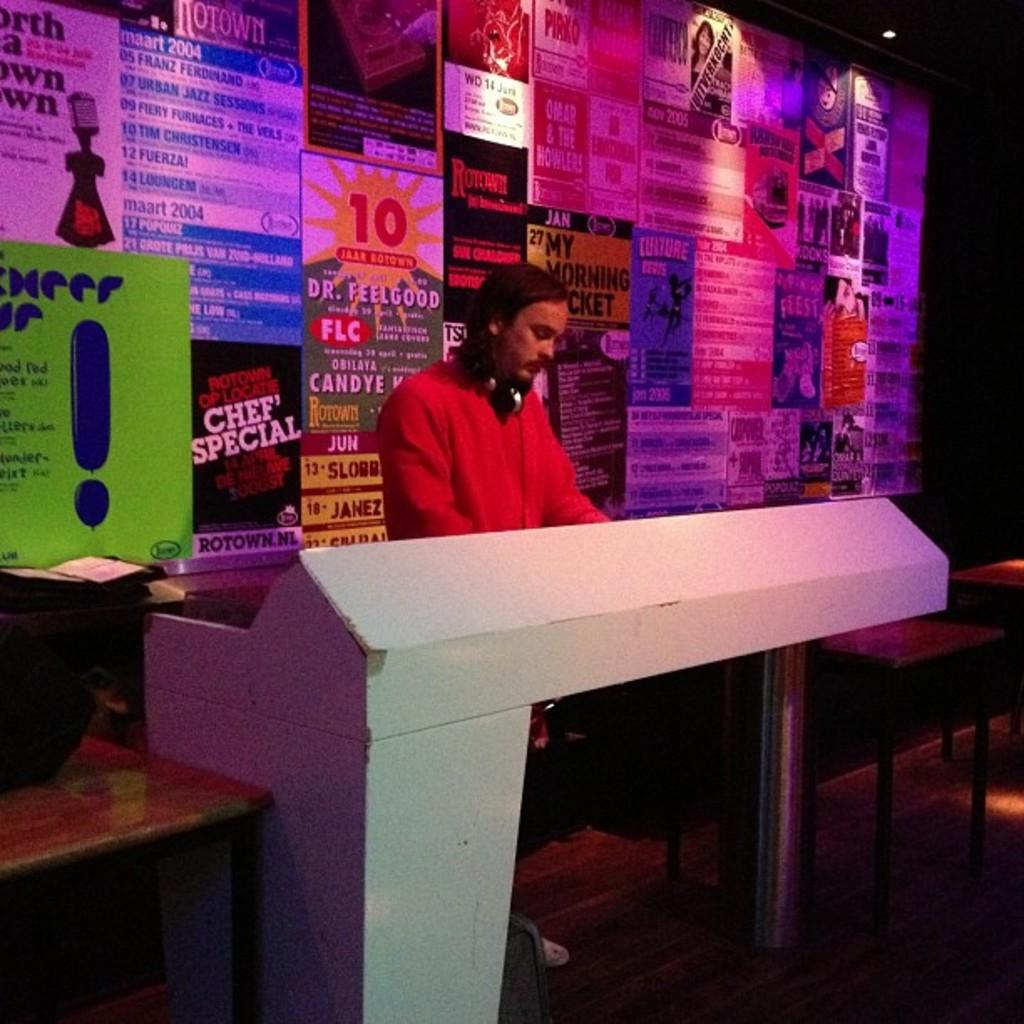Provide a one-sentence caption for the provided image. A DJ stands in front of a wall of concert posters, including one for Dr. Feelgood. 